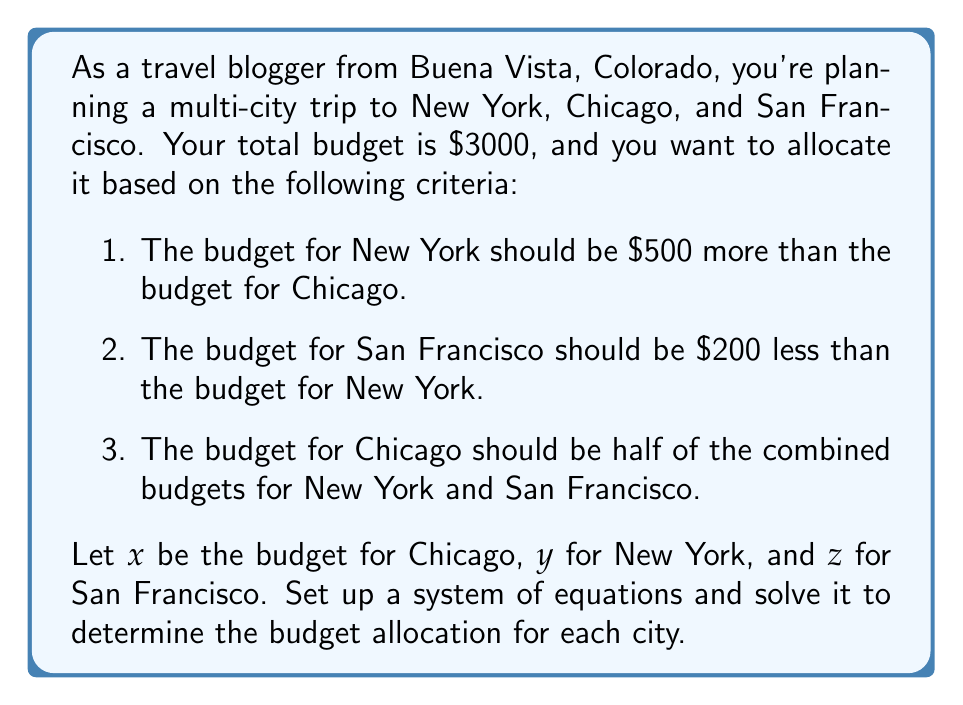Can you solve this math problem? Let's approach this step-by-step:

1. First, we'll translate the given information into equations:

   a) $y = x + 500$ (New York's budget is $500 more than Chicago's)
   b) $z = y - 200$ (San Francisco's budget is $200 less than New York's)
   c) $x = \frac{y + z}{2}$ (Chicago's budget is half of New York's and San Francisco's combined)
   d) $x + y + z = 3000$ (Total budget constraint)

2. Substitute equation (a) into (b):
   $z = (x + 500) - 200 = x + 300$

3. Now we can rewrite equation (c) using (a) and the result from step 2:
   $x = \frac{(x + 500) + (x + 300)}{2} = \frac{2x + 800}{2} = x + 400$

4. This equation is always true, so we can proceed with our known equations:
   $x + y + z = 3000$
   $y = x + 500$
   $z = x + 300$

5. Substitute these into the total budget equation:
   $x + (x + 500) + (x + 300) = 3000$
   $3x + 800 = 3000$
   $3x = 2200$
   $x = \frac{2200}{3} \approx 733.33$

6. Now we can find y and z:
   $y = x + 500 = 733.33 + 500 = 1233.33$
   $z = x + 300 = 733.33 + 300 = 1033.33$

7. Rounding to the nearest dollar:
   Chicago (x): $733
   New York (y): $1233
   San Francisco (z): $1033

8. Verify: $733 + 1233 + 1033 = 2999$ (due to rounding)
Answer: The budget allocation should be:
Chicago: $733
New York: $1233
San Francisco: $1033 